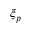<formula> <loc_0><loc_0><loc_500><loc_500>\xi _ { p }</formula> 